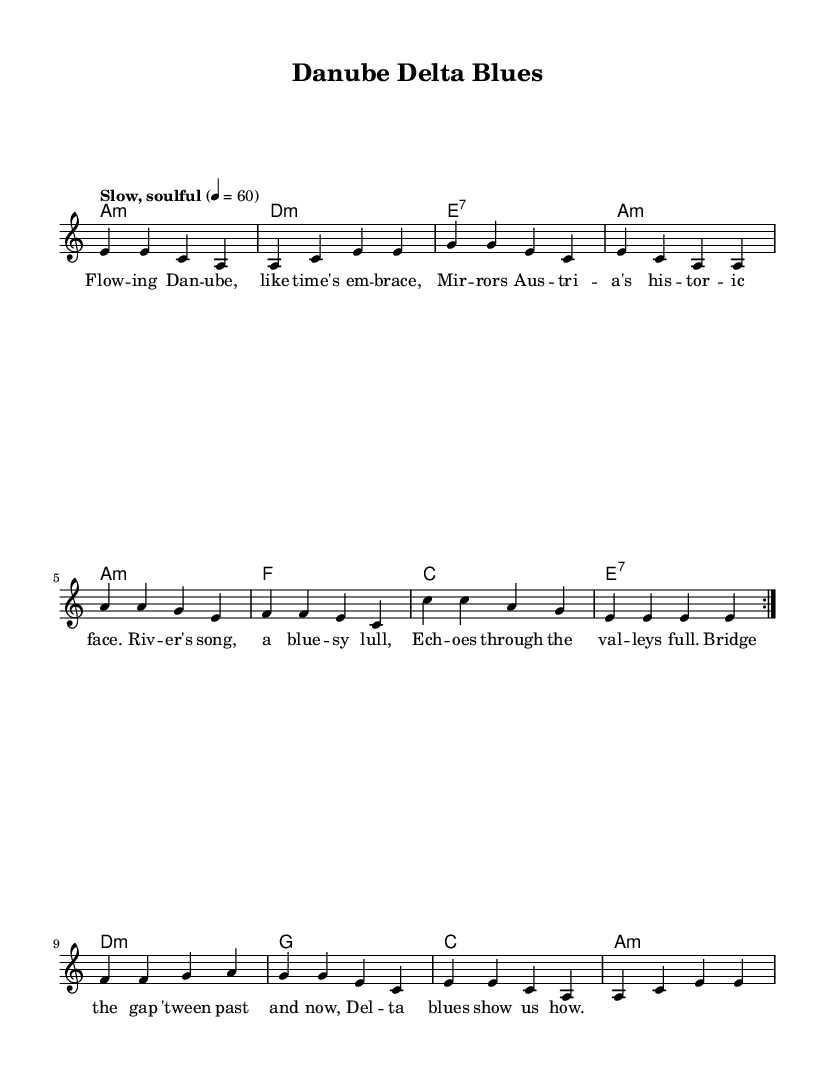What is the key signature of this music? The key signature is indicated by the sharps or flats at the beginning of the staff. Here, there are no sharps or flats shown, which means it is in A minor.
Answer: A minor What is the time signature of this music? The time signature is found at the beginning of the staff and shows how many beats are in each measure. In this case, it is 4/4, meaning there are four beats per measure.
Answer: 4/4 What is the tempo marking in this music? The tempo marking indicates the speed at which the piece should be played and is usually located above the staff. Here, it is marked as "Slow, soulful," indicating a relaxed pace.
Answer: Slow, soulful How many measures are there in the first section? The first section consists of the repeated volta and has a total of 8 measures before it moves into the next part. This can be counted directly from the score.
Answer: 8 What are the first two chords of the harmonies? The first two chords are identified in the chord mode section, which shows the progression. The first chord is A minor and the second chord is D minor.
Answer: A minor, D minor What lyrical theme does the song convey? The overall lyrical theme can be deduced from the words provided, which emphasize the natural beauty and historical value of the Danube. The lyrics incorporate reflections on time and the landscape of Austria.
Answer: Nature and history 